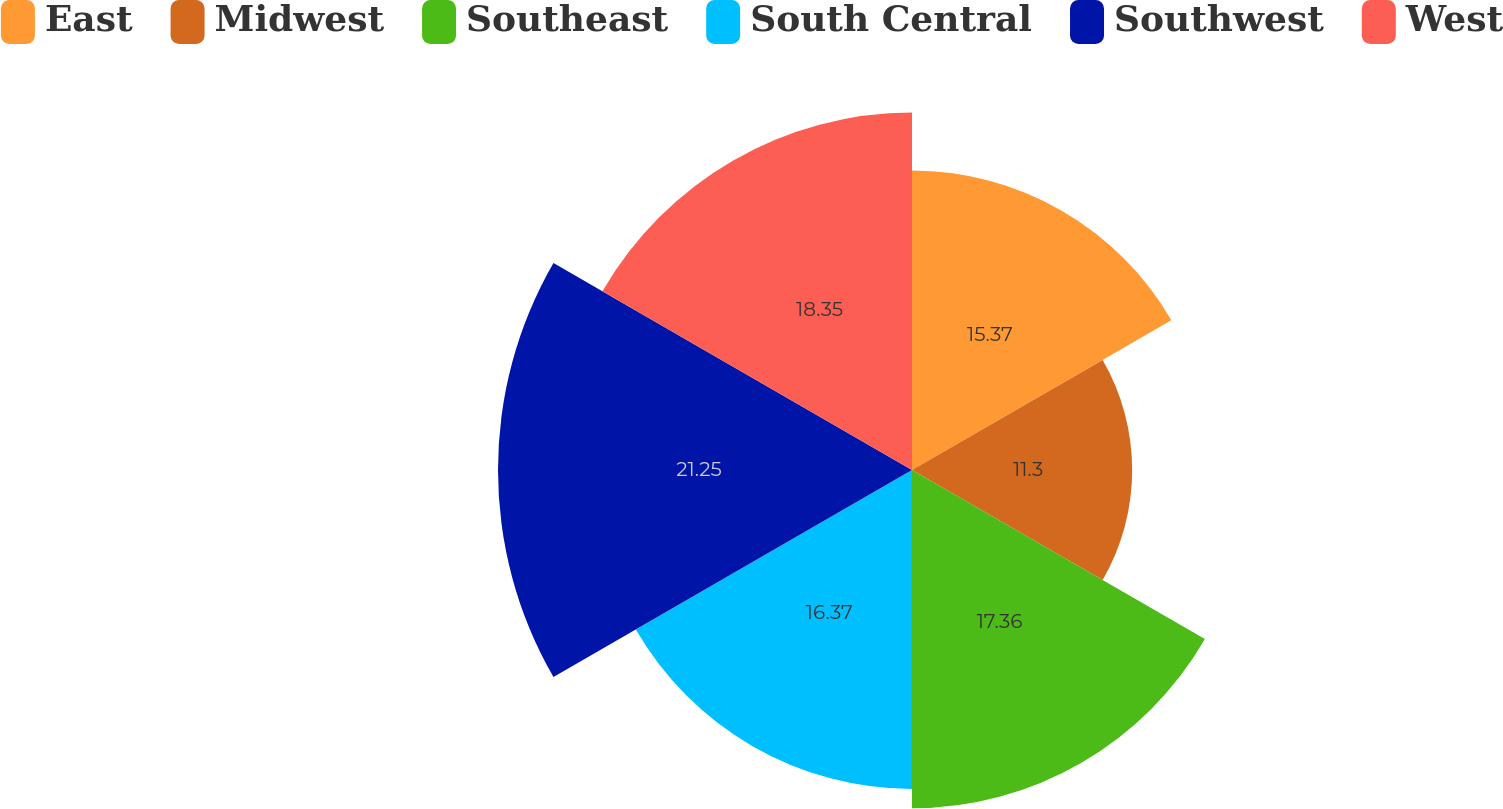<chart> <loc_0><loc_0><loc_500><loc_500><pie_chart><fcel>East<fcel>Midwest<fcel>Southeast<fcel>South Central<fcel>Southwest<fcel>West<nl><fcel>15.37%<fcel>11.3%<fcel>17.36%<fcel>16.37%<fcel>21.25%<fcel>18.35%<nl></chart> 